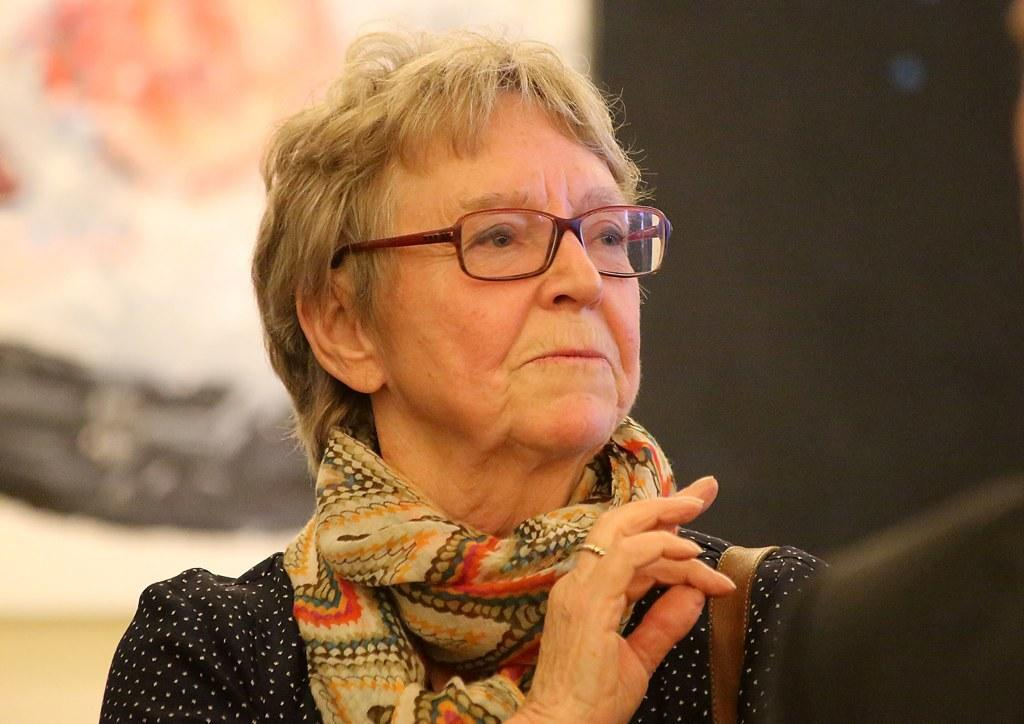Who or what is the main subject of the image? There is a person in the image. What can be observed about the background of the image? The background of the image is blurred. What type of pencil can be seen in the image? There is no pencil present in the image. How many volleyballs are visible in the image? There are no volleyballs visible in the image. 